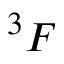Convert formula to latex. <formula><loc_0><loc_0><loc_500><loc_500>^ { 3 } F</formula> 